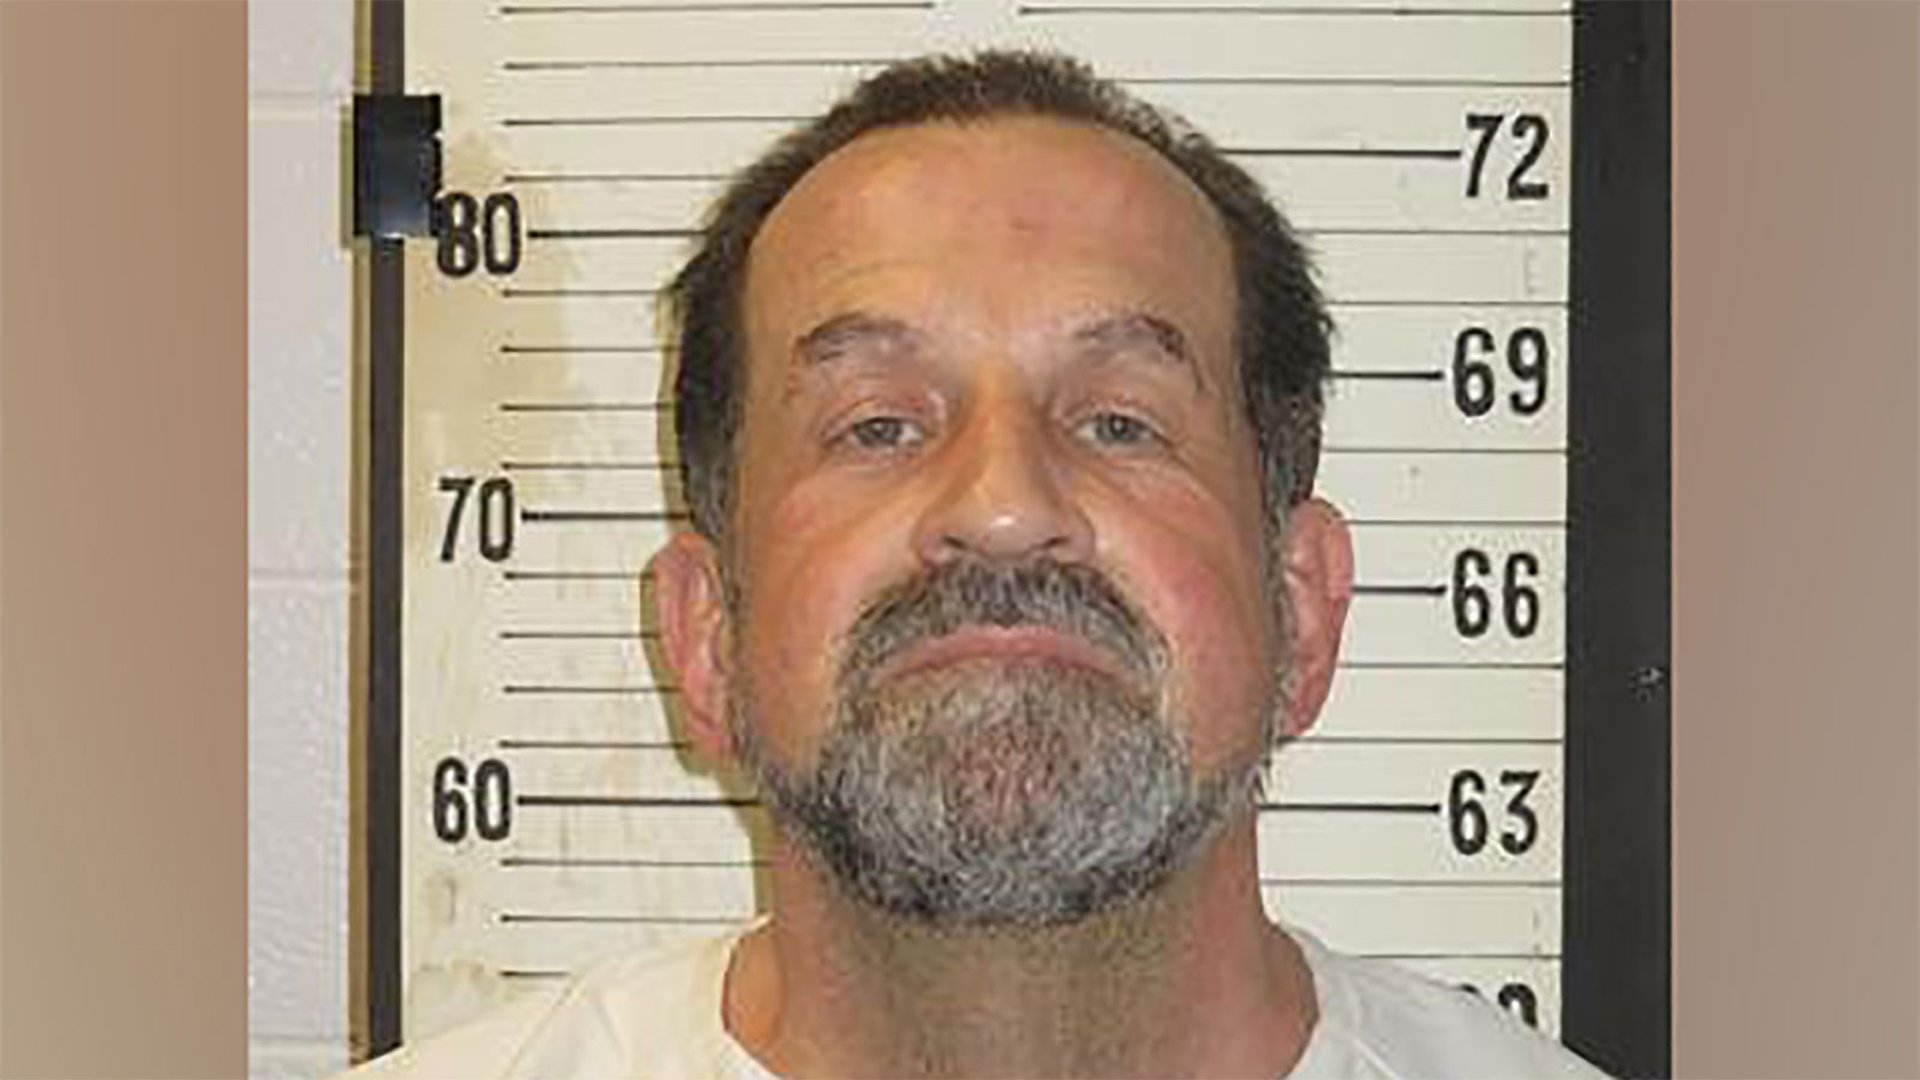Imagine this man was transported into a medieval fantasy world. What role or character might he represent? In a medieval fantasy world, the man could be envisioned as a seasoned warrior or a stern knight given his rugged appearance and strong features. Alternatively, he might play the role of a wise, experienced advisor to the king, someone who has seen many battles and offers strategic counsel. What if he's a wizard? Describe his appearance and powers in detail. If this man were a wizard, he would have a long, flowing robe adorned with mystic symbols and an impressive, silver-tipped staff that radiates power. His eyes, though aged, would gleam with the knowledge of ancient spells. His beard, perhaps longer and more untamed, would add to his enigmatic aura. He might possess the ability to control the elements, with a special affinity for summoning lightning storms and conjuring protective barriers. This wizard would be known for his unparalleled wisdom and his pivotal role in the protection of the realm from dark forces. 